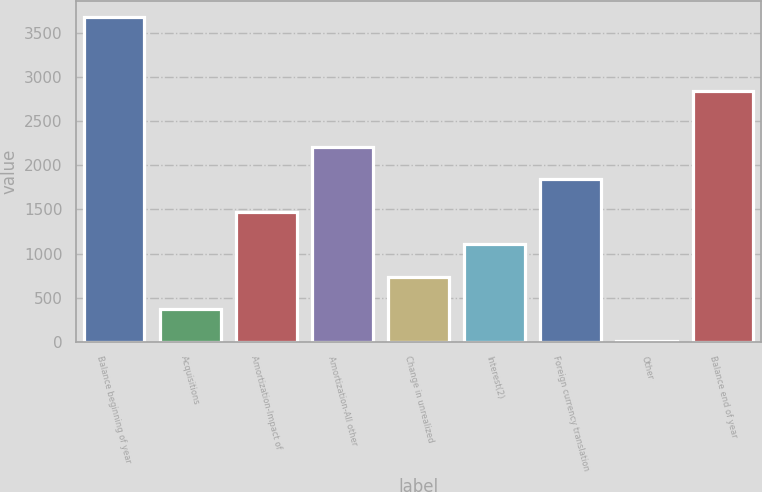Convert chart. <chart><loc_0><loc_0><loc_500><loc_500><bar_chart><fcel>Balance beginning of year<fcel>Acquisitions<fcel>Amortization-Impact of<fcel>Amortization-All other<fcel>Change in unrealized<fcel>Interest(2)<fcel>Foreign currency translation<fcel>Other<fcel>Balance end of year<nl><fcel>3675<fcel>371.78<fcel>1472.87<fcel>2206.91<fcel>738.81<fcel>1105.84<fcel>1839.89<fcel>4.75<fcel>2836<nl></chart> 